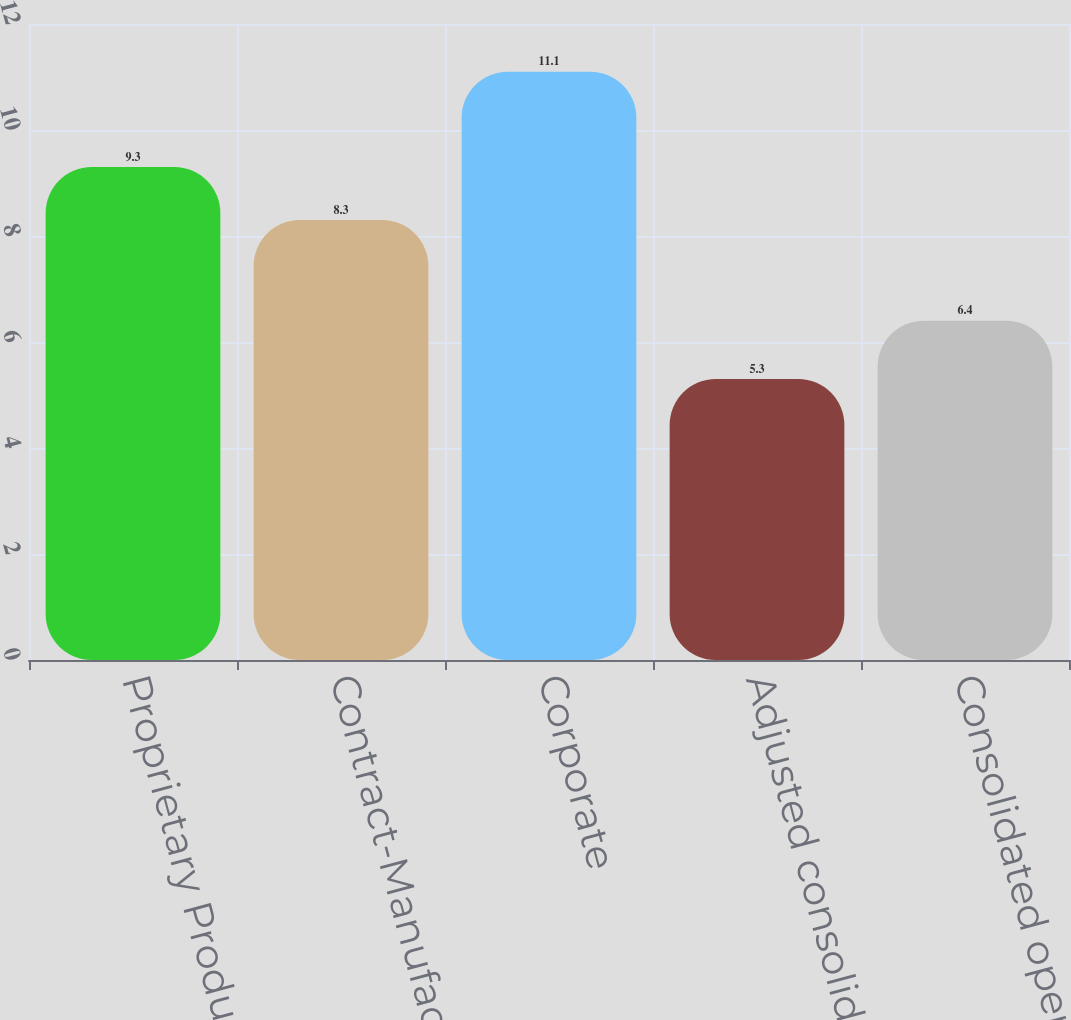<chart> <loc_0><loc_0><loc_500><loc_500><bar_chart><fcel>Proprietary Products<fcel>Contract-Manufactured Products<fcel>Corporate<fcel>Adjusted consolidated<fcel>Consolidated operating profit<nl><fcel>9.3<fcel>8.3<fcel>11.1<fcel>5.3<fcel>6.4<nl></chart> 